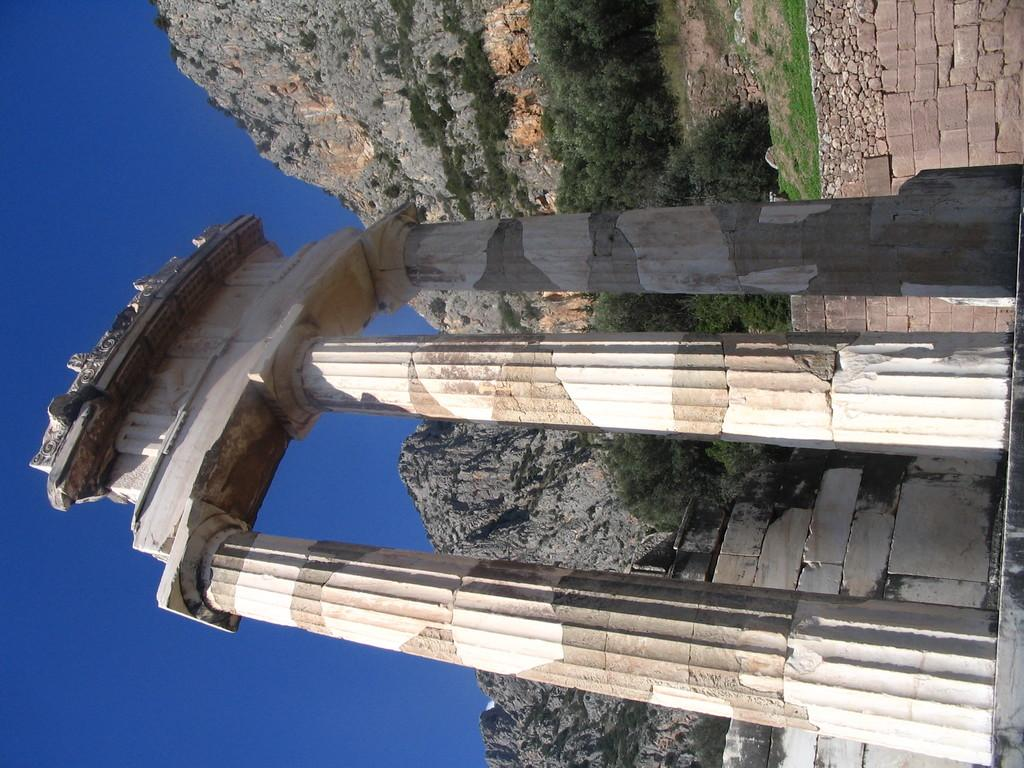What type of structure is in the foreground of the image? There is an architecture with pillars in the foreground of the image. What can be seen in the background of the image? There are mountains, trees, a wall, and the sky visible in the background of the image. How many letters are visible on the architecture in the image? There is no mention of letters on the architecture in the provided facts, so we cannot determine the number of letters visible. 